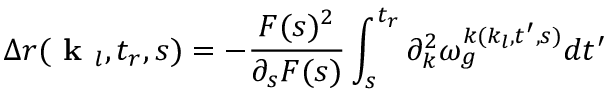<formula> <loc_0><loc_0><loc_500><loc_500>\Delta r ( k _ { l } , t _ { r } , s ) = - \frac { F ( s ) ^ { 2 } } { \partial _ { s } F ( s ) } \int _ { s } ^ { t _ { r } } \partial _ { k } ^ { 2 } \omega _ { g } ^ { k ( k _ { l } , t ^ { \prime } , s ) } d t ^ { \prime }</formula> 